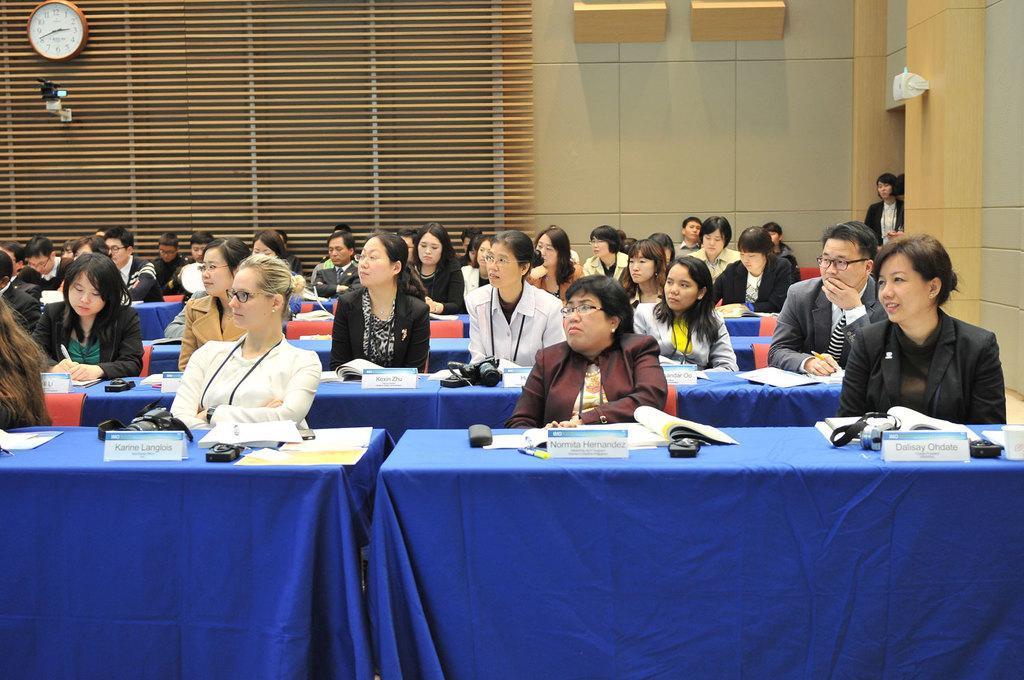Please provide a concise description of this image. As we can see in the image there a wall, few people sitting on chairs and there are table. On tables there are papers, books, mouse and camera. 